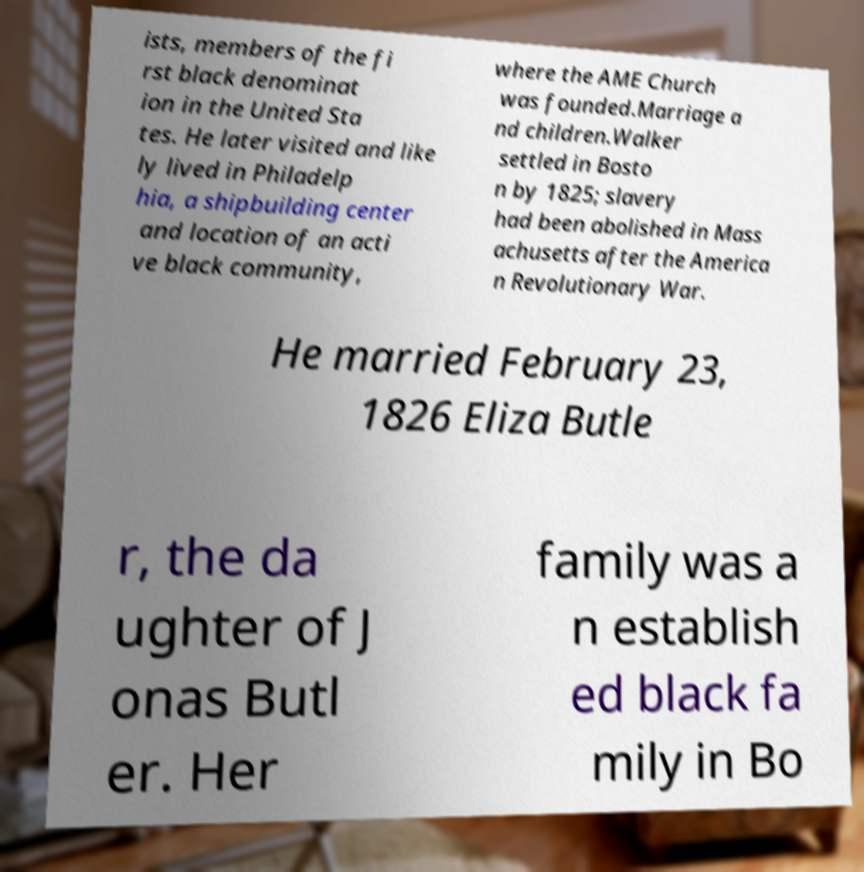I need the written content from this picture converted into text. Can you do that? ists, members of the fi rst black denominat ion in the United Sta tes. He later visited and like ly lived in Philadelp hia, a shipbuilding center and location of an acti ve black community, where the AME Church was founded.Marriage a nd children.Walker settled in Bosto n by 1825; slavery had been abolished in Mass achusetts after the America n Revolutionary War. He married February 23, 1826 Eliza Butle r, the da ughter of J onas Butl er. Her family was a n establish ed black fa mily in Bo 